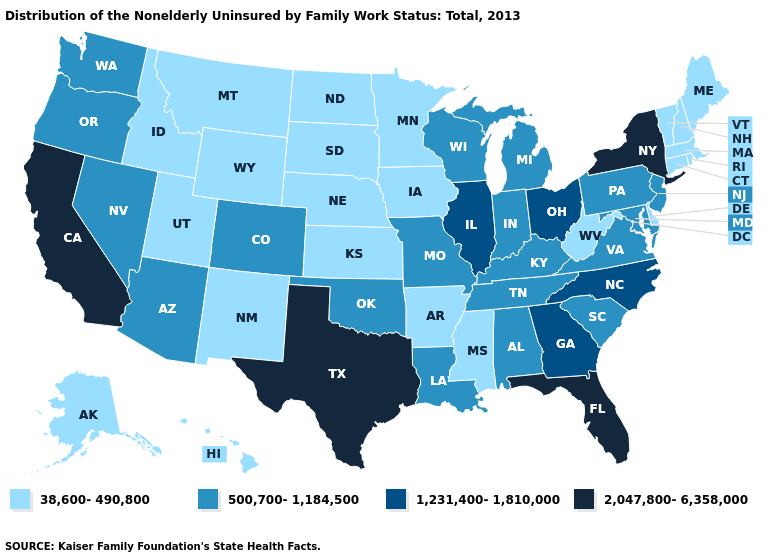Does Florida have a higher value than California?
Be succinct. No. What is the value of Arizona?
Write a very short answer. 500,700-1,184,500. Among the states that border Louisiana , which have the highest value?
Keep it brief. Texas. Does Idaho have the highest value in the USA?
Answer briefly. No. Among the states that border Ohio , which have the highest value?
Give a very brief answer. Indiana, Kentucky, Michigan, Pennsylvania. What is the lowest value in states that border Mississippi?
Write a very short answer. 38,600-490,800. What is the value of South Carolina?
Concise answer only. 500,700-1,184,500. Does Connecticut have the lowest value in the USA?
Short answer required. Yes. Does Alabama have a lower value than Texas?
Give a very brief answer. Yes. What is the value of South Dakota?
Be succinct. 38,600-490,800. Name the states that have a value in the range 1,231,400-1,810,000?
Keep it brief. Georgia, Illinois, North Carolina, Ohio. Name the states that have a value in the range 1,231,400-1,810,000?
Be succinct. Georgia, Illinois, North Carolina, Ohio. What is the value of Hawaii?
Be succinct. 38,600-490,800. Which states have the highest value in the USA?
Answer briefly. California, Florida, New York, Texas. 